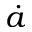<formula> <loc_0><loc_0><loc_500><loc_500>\dot { a }</formula> 